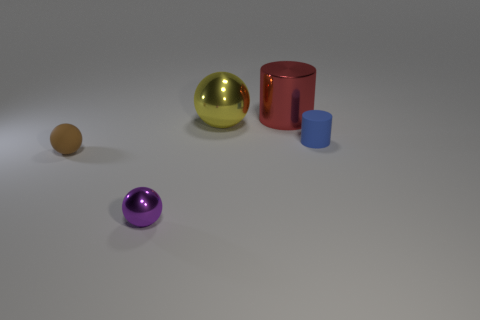The small shiny object has what shape?
Ensure brevity in your answer.  Sphere. There is a big thing in front of the red cylinder; what is it made of?
Provide a succinct answer. Metal. What is the size of the sphere left of the metal thing in front of the small matte thing that is on the left side of the red cylinder?
Ensure brevity in your answer.  Small. Are the ball right of the purple ball and the cylinder right of the red shiny cylinder made of the same material?
Your answer should be very brief. No. How many objects are either shiny balls that are on the left side of the big yellow object or things that are to the left of the small blue cylinder?
Your answer should be very brief. 4. There is a thing on the right side of the metal cylinder to the right of the brown object; what is its size?
Your response must be concise. Small. The blue cylinder has what size?
Give a very brief answer. Small. There is a metallic object to the left of the yellow shiny thing; is its color the same as the tiny rubber thing that is right of the brown matte thing?
Your response must be concise. No. What number of other objects are the same material as the tiny blue cylinder?
Offer a terse response. 1. Are any large brown matte cubes visible?
Keep it short and to the point. No. 